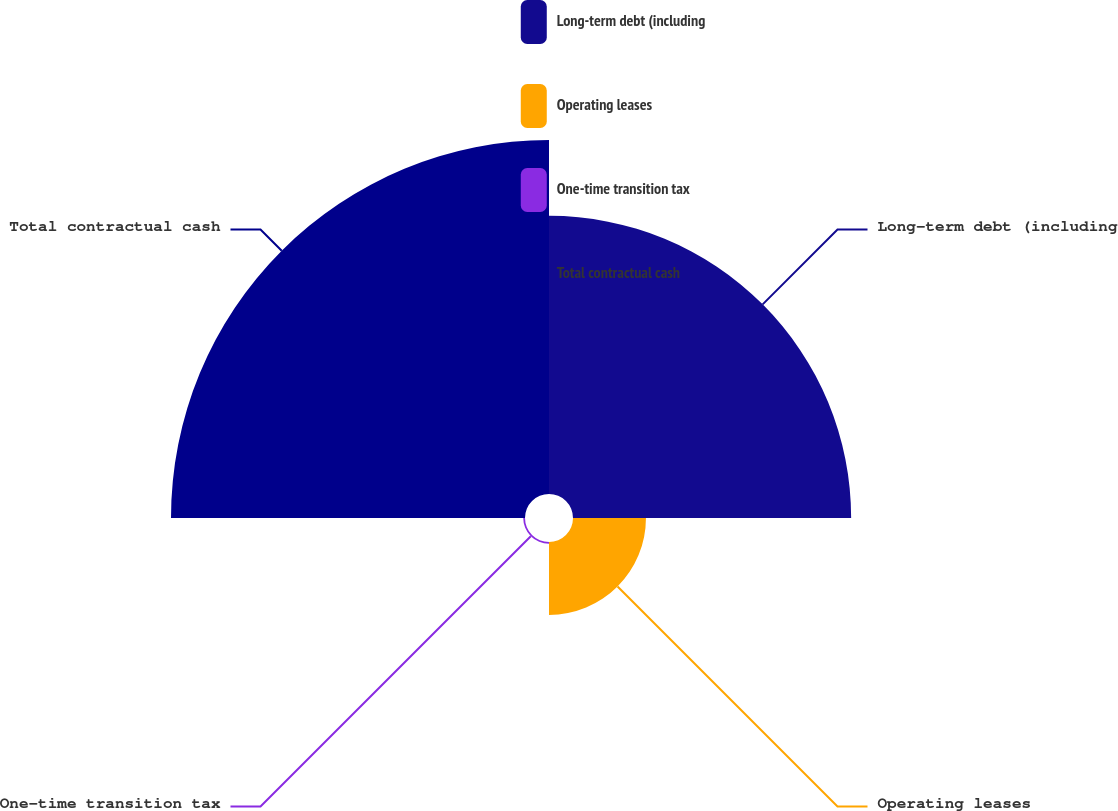<chart> <loc_0><loc_0><loc_500><loc_500><pie_chart><fcel>Long-term debt (including<fcel>Operating leases<fcel>One-time transition tax<fcel>Total contractual cash<nl><fcel>39.35%<fcel>10.32%<fcel>0.25%<fcel>50.08%<nl></chart> 